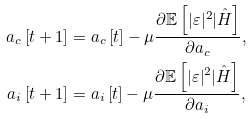<formula> <loc_0><loc_0><loc_500><loc_500>a _ { c } \left [ t + 1 \right ] & = a _ { c } \left [ t \right ] - \mu \frac { \partial \mathbb { E } \left [ | \varepsilon | ^ { 2 } | \hat { H } \right ] } { \partial a _ { c } } , \\ a _ { i } \left [ t + 1 \right ] & = a _ { i } \left [ t \right ] - \mu \frac { \partial \mathbb { E } \left [ | \varepsilon | ^ { 2 } | \hat { H } \right ] } { \partial a _ { i } } ,</formula> 